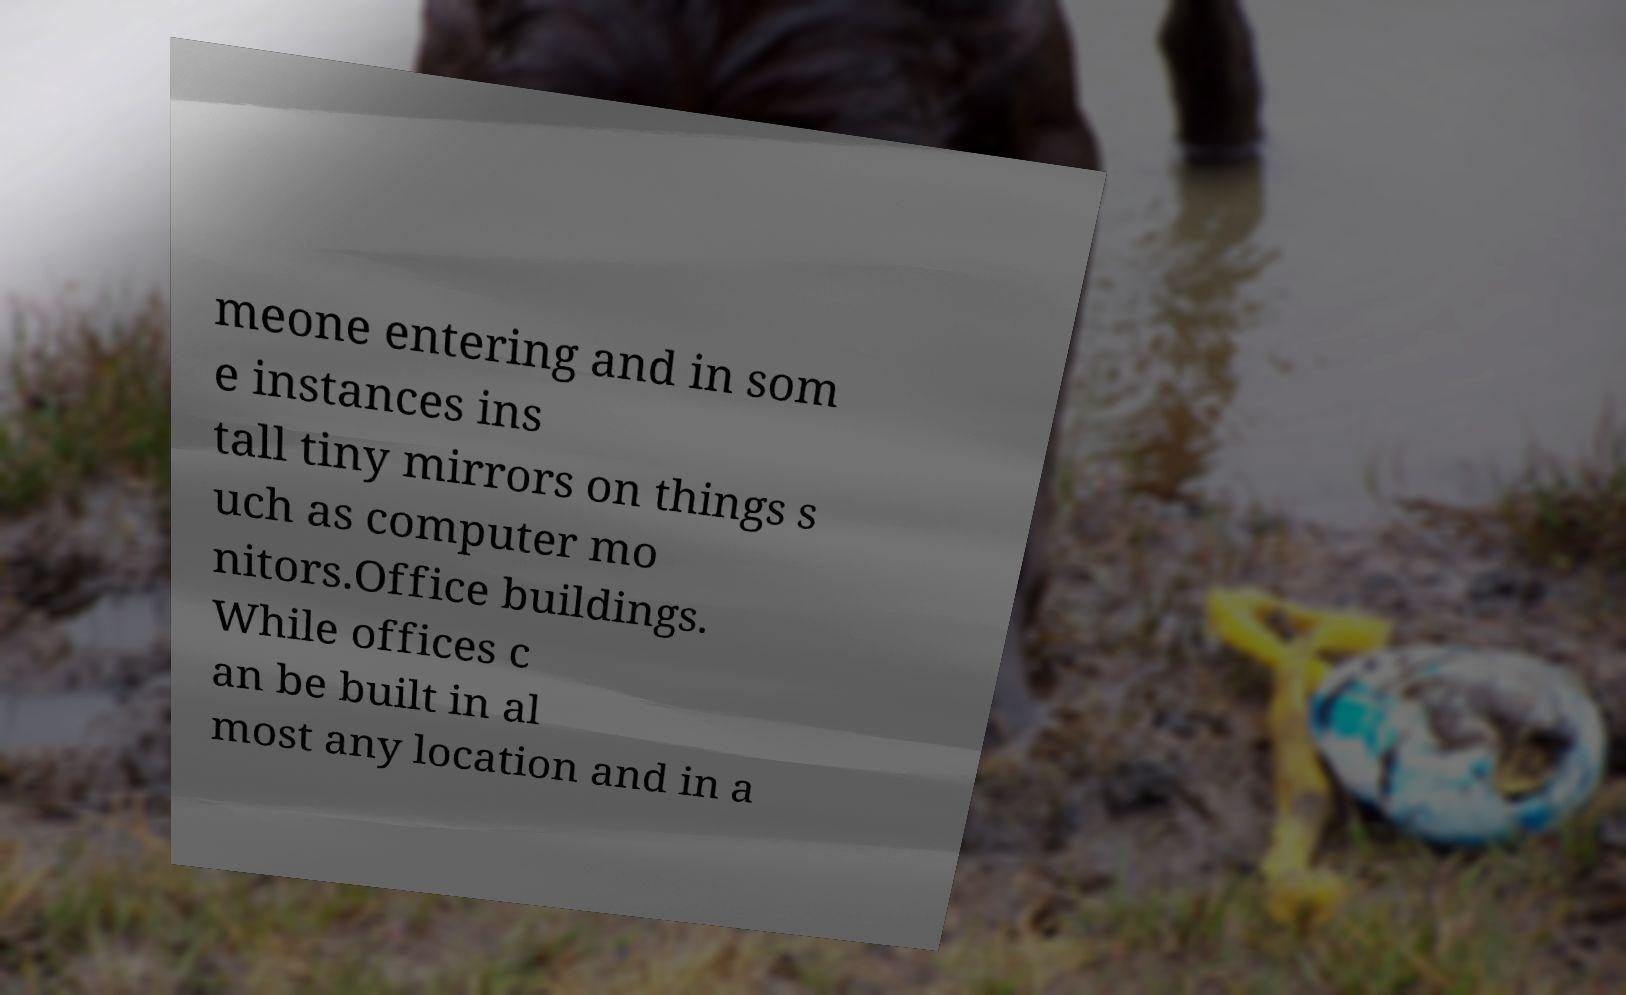Please read and relay the text visible in this image. What does it say? meone entering and in som e instances ins tall tiny mirrors on things s uch as computer mo nitors.Office buildings. While offices c an be built in al most any location and in a 